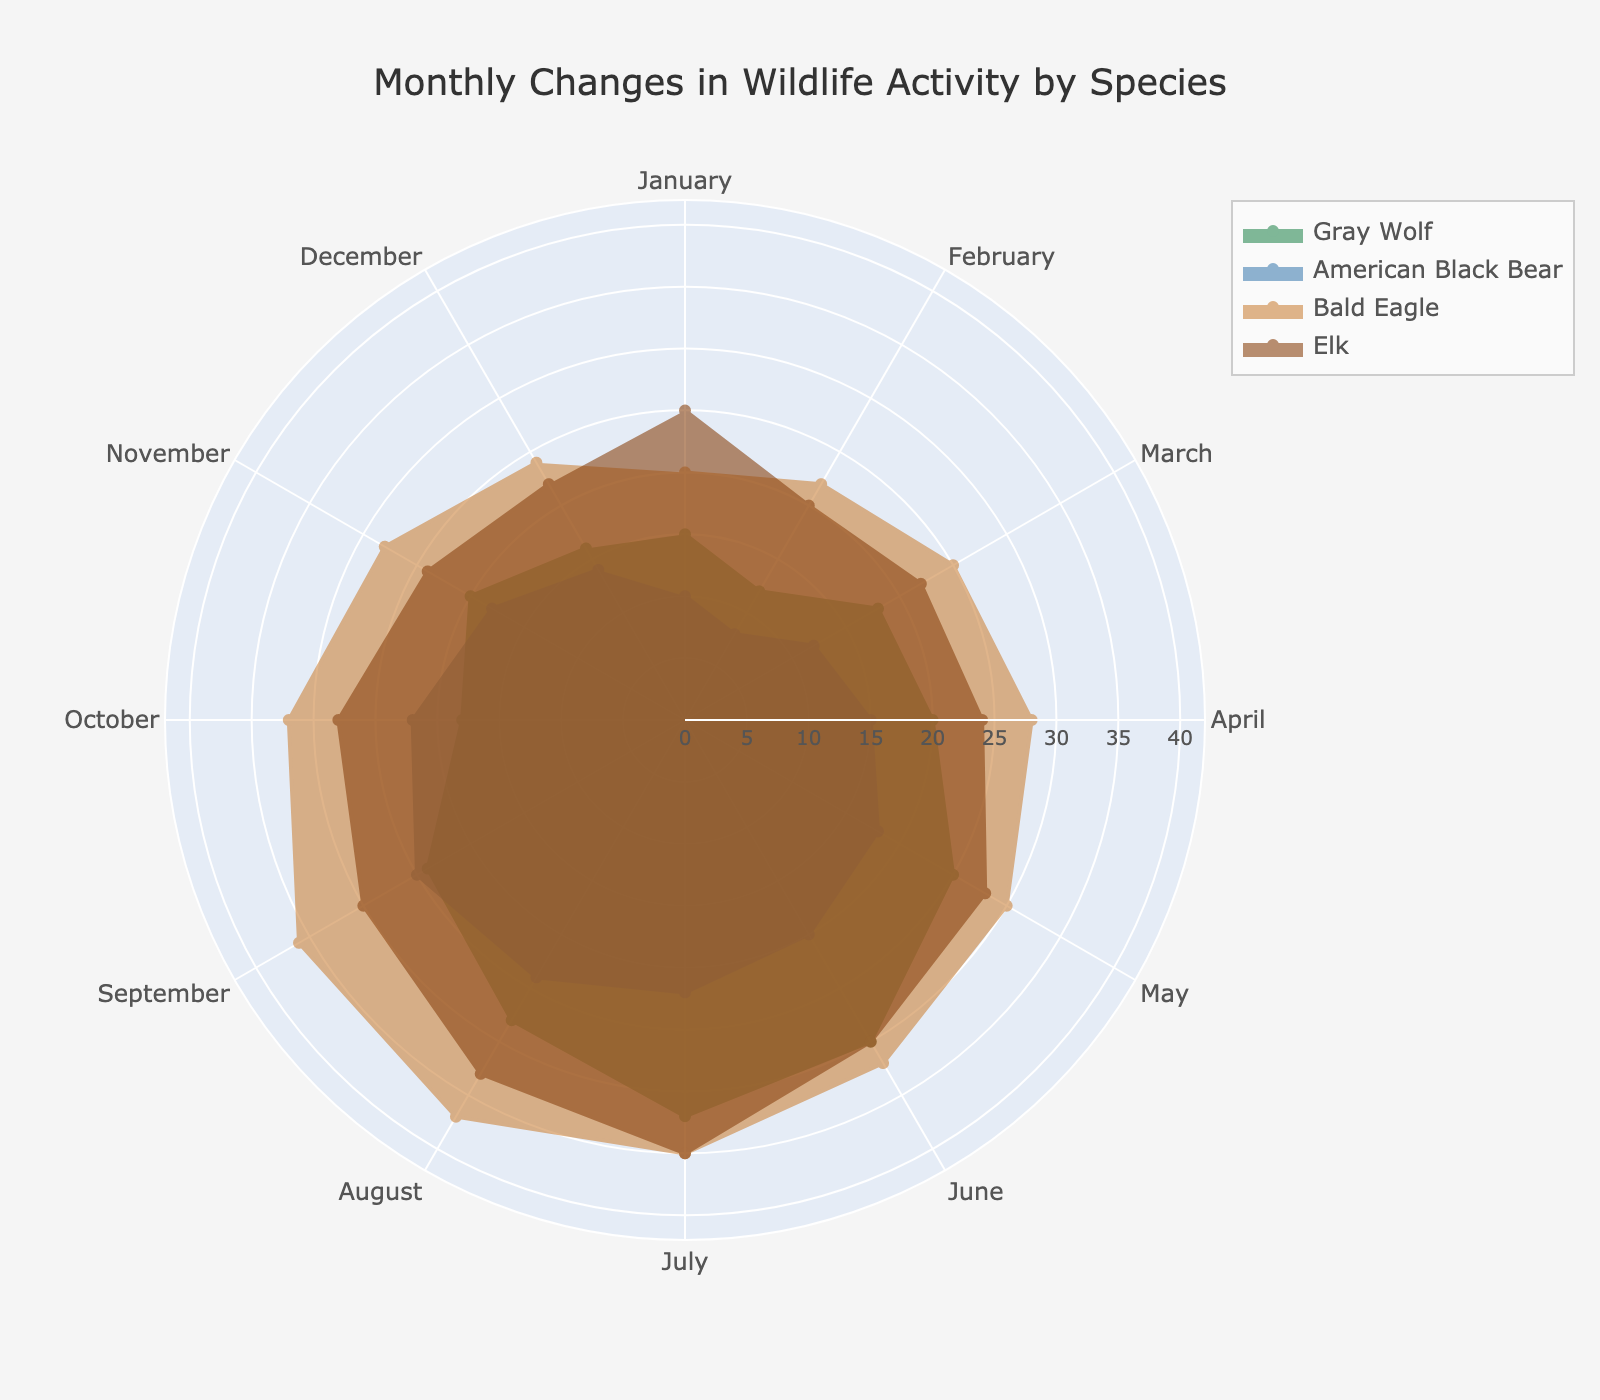What is the title of the radar chart? The title is typically located at the top of the figure. In this case, it is "Monthly Changes in Wildlife Activity by Species".
Answer: Monthly Changes in Wildlife Activity by Species Which species shows the highest activity in July? By looking at the values in July for each species, the highest value is for the Bald Eagle at 35.
Answer: Bald Eagle What is the range of the radial axis? The radial axis range is indicated by its maximum value plus an additional margin. The highest value among the species' monthly activities is 37 (Bald Eagle in August), so the range is from 0 to 42.
Answer: 0 to 42 Which month sees the minimum activity for the American Black Bear? By looking at the radar chart, the lowest activity value for the American Black Bear is in February, which is 8.
Answer: February What color represents the Gray Wolf on the radar chart? Each species is distinctively colored. The Gray Wolf is represented by a shade of green.
Answer: Green In which months does the Bald Eagle have more activity compared to the Elk? By comparing the values of Bald Eagle and Elk for each month, the Bald Eagle has higher values in February, March, April, May, June, July, August, October, November, and December.
Answer: February, March, April, May, June, July, August, October, November, December How much greater is the activity of the Bald Eagle in December compared to January? The activity of the Bald Eagle in December is 24 and in January is 20. The difference is 24 - 20 = 4.
Answer: 4 Which species displays the largest increase in activity from January to July? Calculate the difference in activity from January to July for each species: Gray Wolf (17), American Black Bear (12), Bald Eagle (15), Elk (10). The Gray Wolf shows the largest increase.
Answer: Gray Wolf What is the average activity of the Gray Wolf in the spring months (March, April, and May)? The values for the Gray Wolf in March, April, and May are 18, 20, and 25 respectively. The average is (18 + 20 + 25) / 3 = 21.
Answer: 21 How does the activity of the Elk change across the summer months (June, July, and August)? The values for the Elk in June, July, and August are 30, 35, and 33 respectively. The activity increases from June to July by 5 and then decreases from July to August by 2.
Answer: Increases by 5, then decreases by 2 